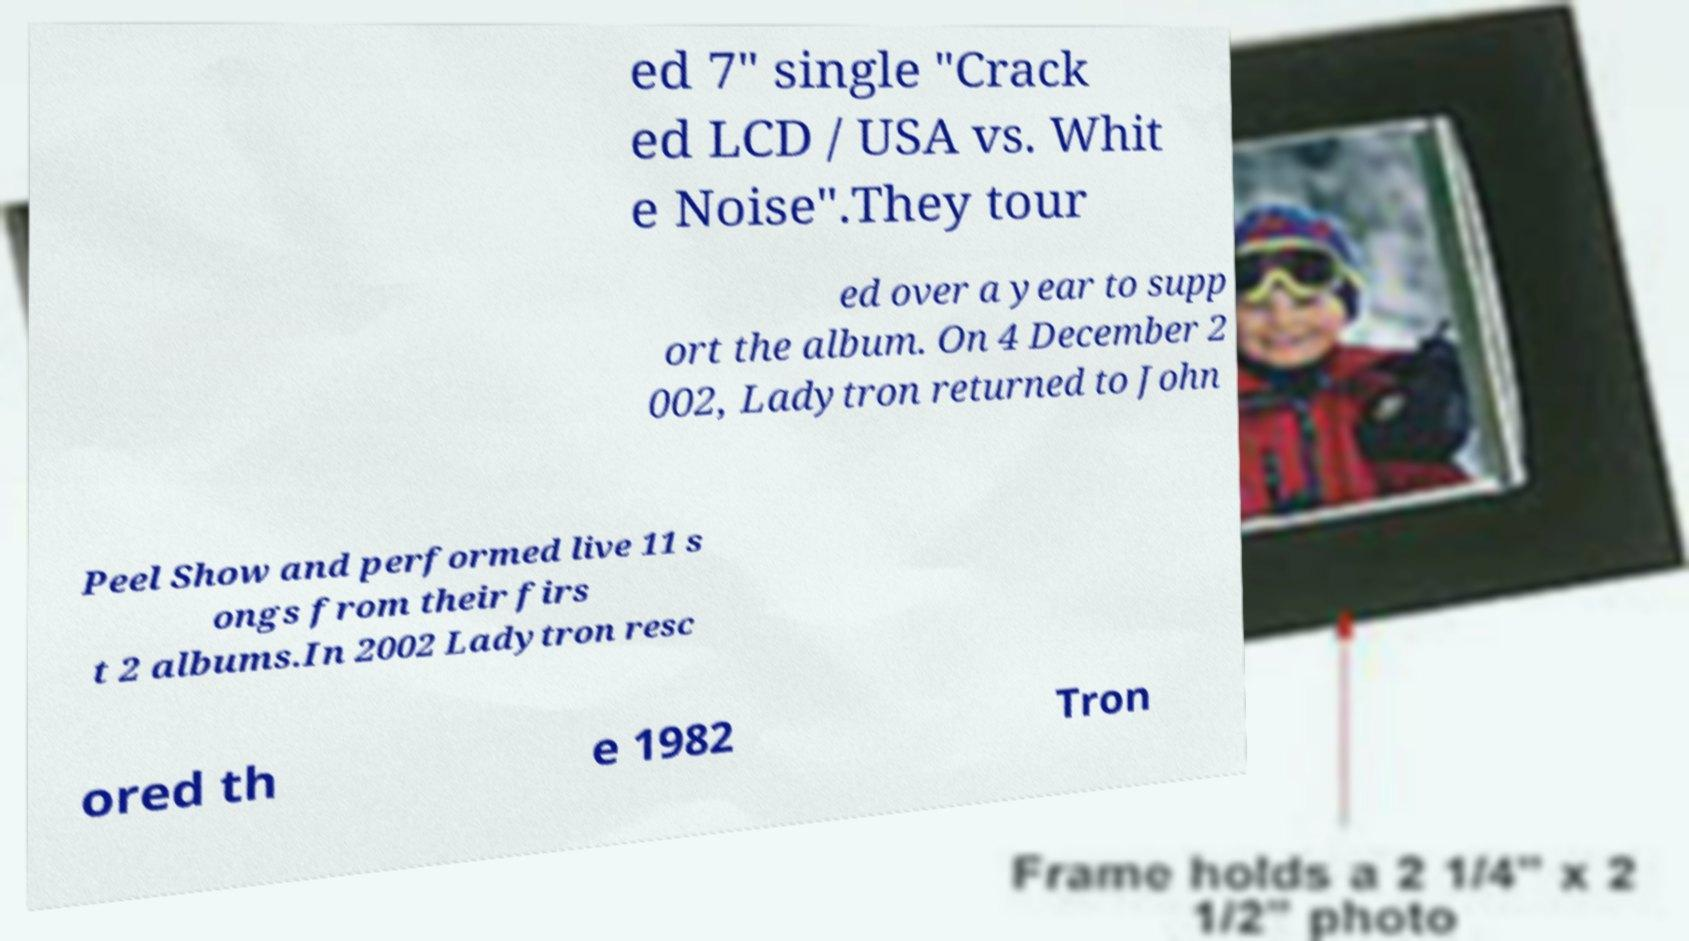Can you read and provide the text displayed in the image?This photo seems to have some interesting text. Can you extract and type it out for me? ed 7" single "Crack ed LCD / USA vs. Whit e Noise".They tour ed over a year to supp ort the album. On 4 December 2 002, Ladytron returned to John Peel Show and performed live 11 s ongs from their firs t 2 albums.In 2002 Ladytron resc ored th e 1982 Tron 